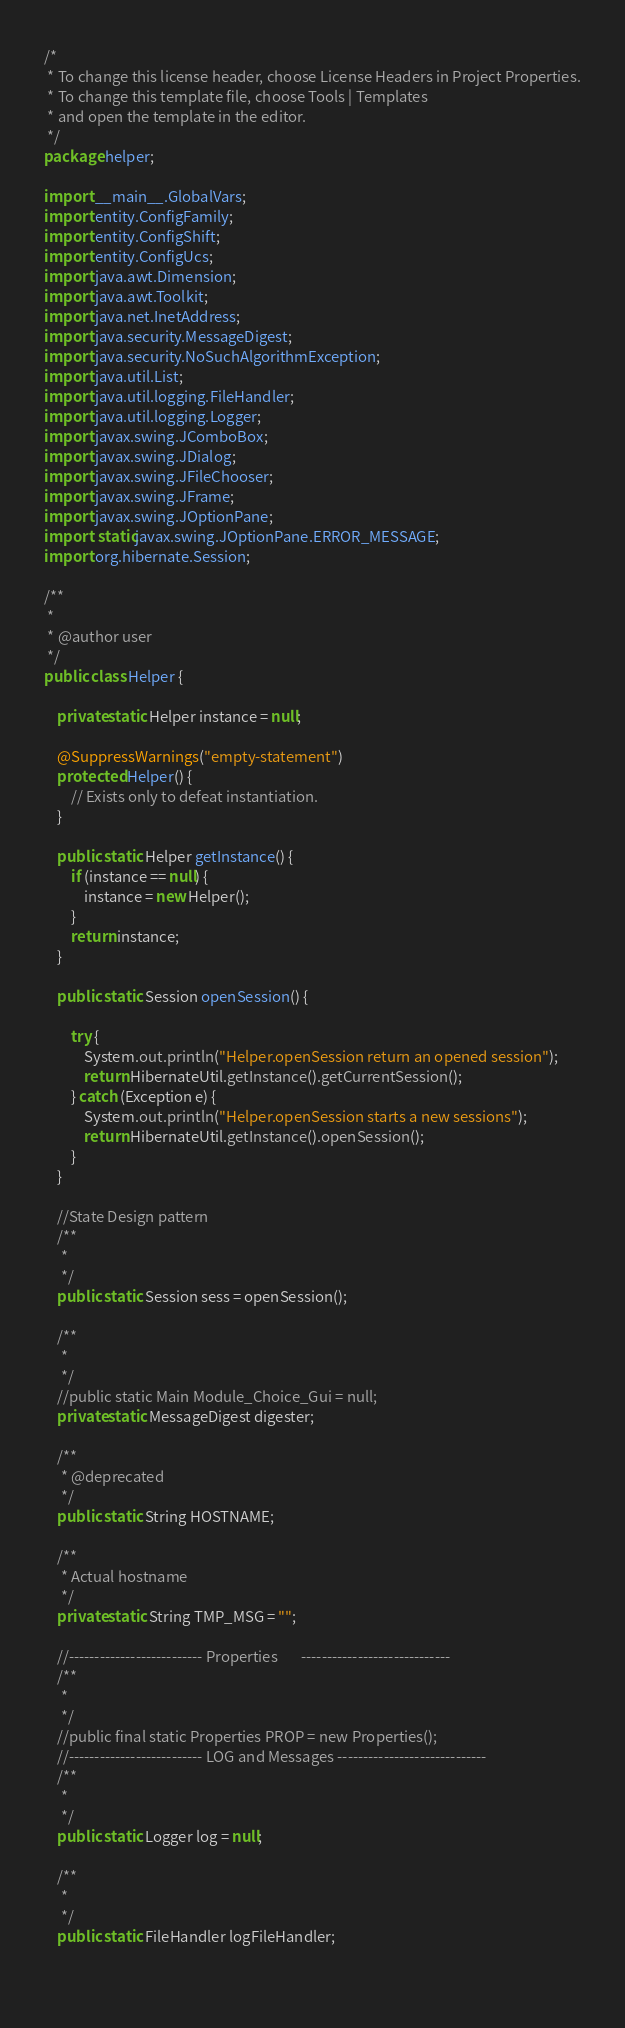<code> <loc_0><loc_0><loc_500><loc_500><_Java_>/*
 * To change this license header, choose License Headers in Project Properties.
 * To change this template file, choose Tools | Templates
 * and open the template in the editor.
 */
package helper;

import __main__.GlobalVars;
import entity.ConfigFamily;
import entity.ConfigShift;
import entity.ConfigUcs;
import java.awt.Dimension;
import java.awt.Toolkit;
import java.net.InetAddress;
import java.security.MessageDigest;
import java.security.NoSuchAlgorithmException;
import java.util.List;
import java.util.logging.FileHandler;
import java.util.logging.Logger;
import javax.swing.JComboBox;
import javax.swing.JDialog;
import javax.swing.JFileChooser;
import javax.swing.JFrame;
import javax.swing.JOptionPane;
import static javax.swing.JOptionPane.ERROR_MESSAGE;
import org.hibernate.Session;

/**
 *
 * @author user
 */
public class Helper {

    private static Helper instance = null;

    @SuppressWarnings("empty-statement")
    protected Helper() {
        // Exists only to defeat instantiation.        
    }

    public static Helper getInstance() {
        if (instance == null) {
            instance = new Helper();
        }
        return instance;
    }

    public static Session openSession() {

        try {
            System.out.println("Helper.openSession return an opened session");
            return HibernateUtil.getInstance().getCurrentSession();
        } catch (Exception e) {
            System.out.println("Helper.openSession starts a new sessions");
            return HibernateUtil.getInstance().openSession();
        }
    }

    //State Design pattern
    /**
     *
     */
    public static Session sess = openSession();

    /**
     *
     */
    //public static Main Module_Choice_Gui = null;
    private static MessageDigest digester;

    /**
     * @deprecated
     */
    public static String HOSTNAME;

    /**
     * Actual hostname
     */
    private static String TMP_MSG = "";

    //-------------------------- Properties       -----------------------------
    /**
     *
     */
    //public final static Properties PROP = new Properties();
    //-------------------------- LOG and Messages -----------------------------
    /**
     *
     */
    public static Logger log = null;

    /**
     *
     */
    public static FileHandler logFileHandler;

    </code> 